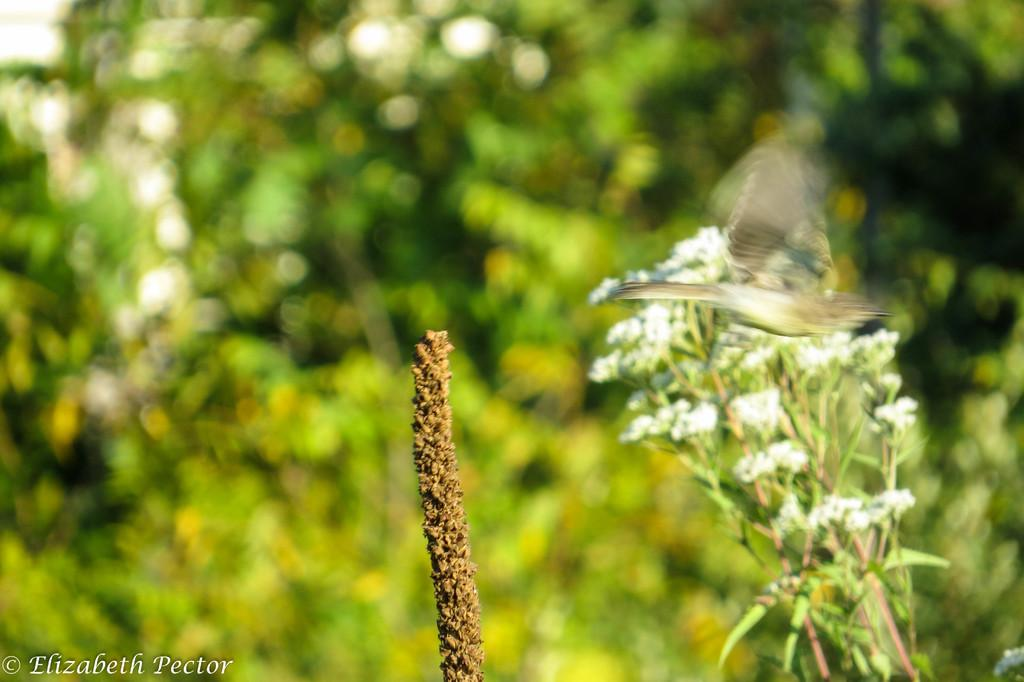What type of animal can be seen in the image? There is a bird visible in the image. Where is the bird located? The bird is on a bunch of flowers. Can you describe the background of the image? The background of the image is blurry. How many sticks are being used to support the cherry tree in the image? There is no cherry tree or sticks present in the image; it features a bird on a bunch of flowers. 